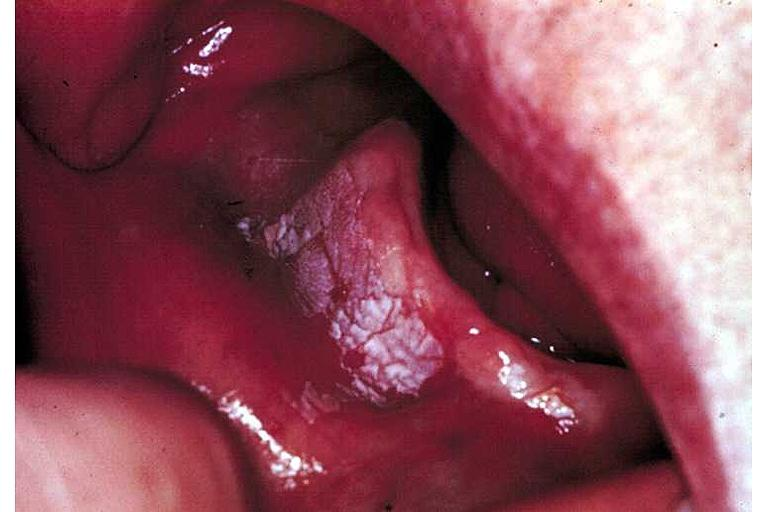does fibrous meningioma show leukoplakia?
Answer the question using a single word or phrase. No 